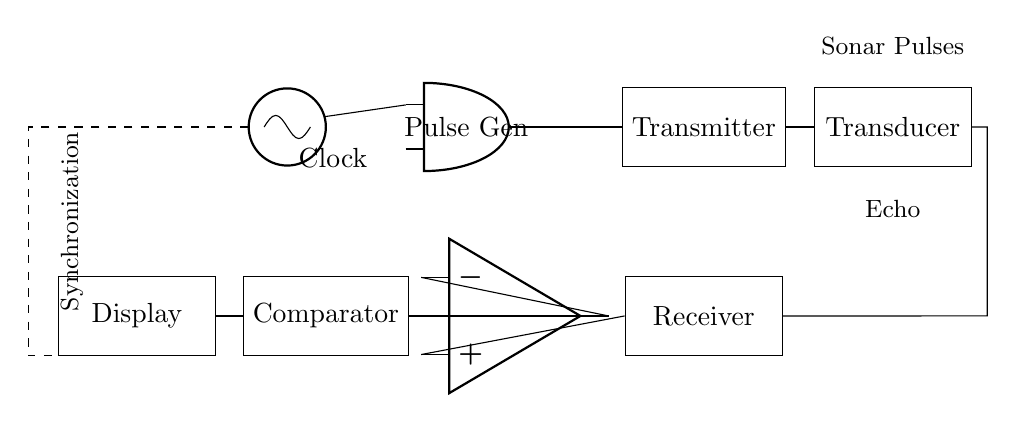What type of oscillator is used in this circuit? The circuit uses a clock oscillator, which is indicated by the node labeled "Clock." This component generates a timing signal necessary for synchronizing operations within the circuit.
Answer: Clock What component generates the sonar pulses? The component generating the sonar pulses is the Pulse Generator, depicted as "Pulse Gen" in the circuit. It receives input from the clock oscillator to produce the pulses used for transmission.
Answer: Pulse Generator What comes after the Transmitter in the signal flow? After the Transmitter, the next component in the flow is the Transducer. This component converts the transmitted electrical signals into sonar waves, which are crucial for the fish finder function.
Answer: Transducer How many main components are there in the circuit? By tallying the components, we find six main elements: Clock, Pulse Generator, Transmitter, Transducer, Receiver, and Comparator. Each of these plays a vital role in the sensing and processing of the sonar signals.
Answer: Six What does the dashed line represent in the circuit? The dashed line represents a synchronization line, indicating the connection between the Clock and the Display. This synchronization is crucial for ensuring that the display shows data in real-time according to the sonar pulses.
Answer: Synchronization Which component amplifies the signal? The component that amplifies the signal is the Op-Amp, depicted in the circuit. It enhances the signal from the Receiver before it is processed further by the Comparator.
Answer: Op-Amp What is the output of the Comparator connected to? The output of the Comparator is connected to the Display. This connection conveys the processed signal, allowing the user to visualize the information derived from the sonar echoes.
Answer: Display 